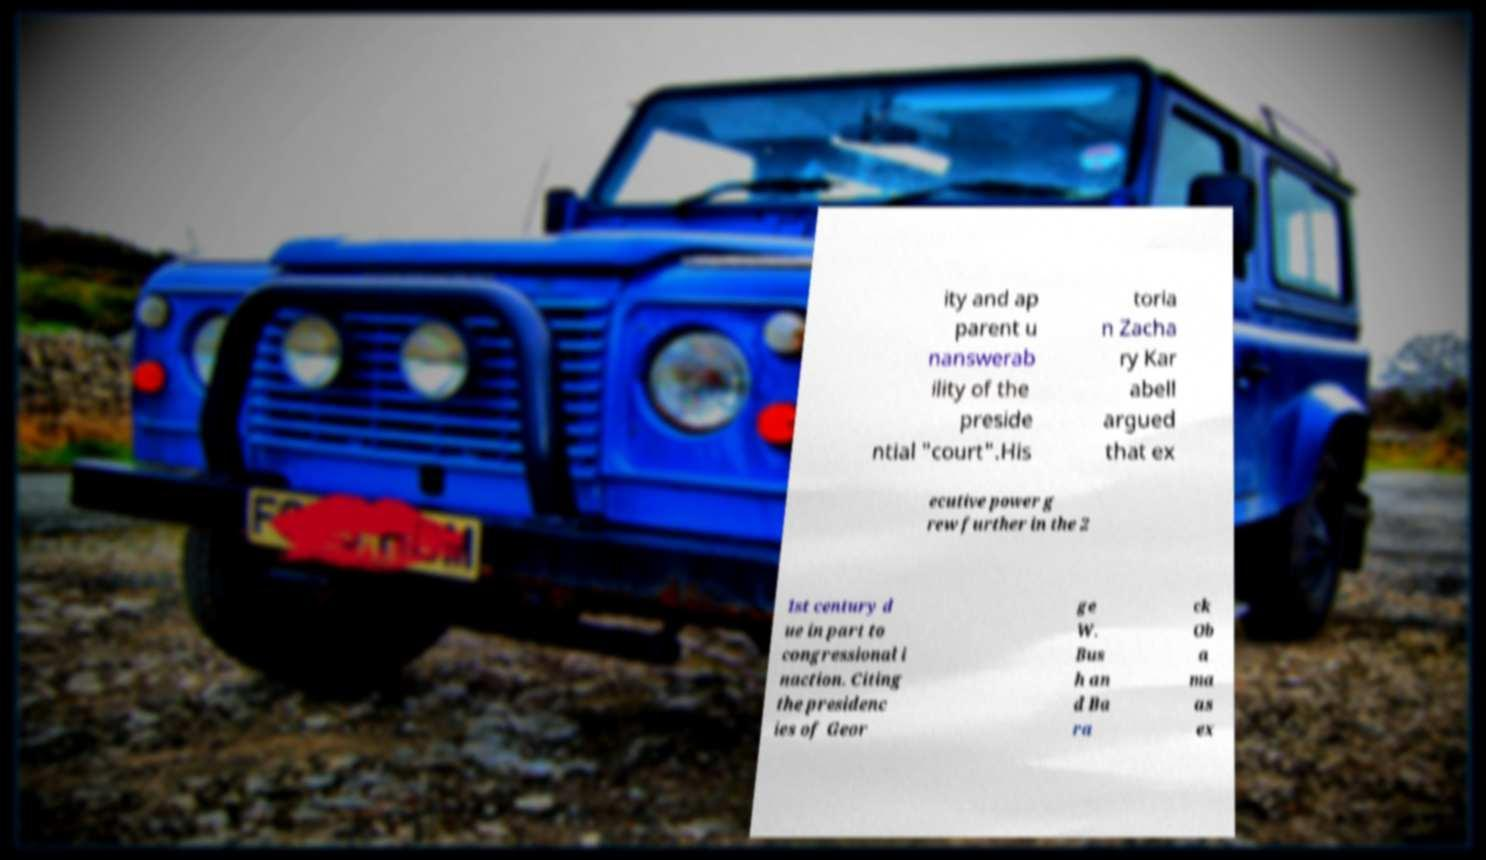For documentation purposes, I need the text within this image transcribed. Could you provide that? ity and ap parent u nanswerab ility of the preside ntial "court".His toria n Zacha ry Kar abell argued that ex ecutive power g rew further in the 2 1st century d ue in part to congressional i naction. Citing the presidenc ies of Geor ge W. Bus h an d Ba ra ck Ob a ma as ex 